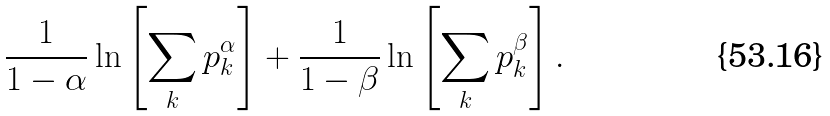<formula> <loc_0><loc_0><loc_500><loc_500>\frac { 1 } { 1 - \alpha } \ln \left [ \sum _ { k } p _ { k } ^ { \alpha } \right ] + \frac { 1 } { 1 - \beta } \ln \left [ \sum _ { k } p _ { k } ^ { \beta } \right ] .</formula> 